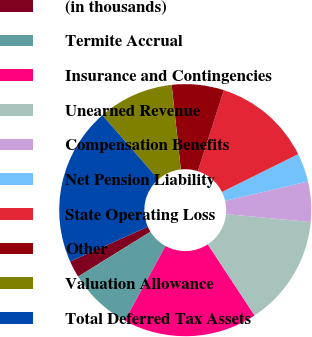Convert chart. <chart><loc_0><loc_0><loc_500><loc_500><pie_chart><fcel>(in thousands)<fcel>Termite Accrual<fcel>Insurance and Contingencies<fcel>Unearned Revenue<fcel>Compensation Benefits<fcel>Net Pension Liability<fcel>State Operating Loss<fcel>Other<fcel>Valuation Allowance<fcel>Total Deferred Tax Assets<nl><fcel>2.16%<fcel>8.19%<fcel>17.24%<fcel>14.22%<fcel>5.17%<fcel>3.67%<fcel>12.71%<fcel>6.68%<fcel>9.7%<fcel>20.25%<nl></chart> 